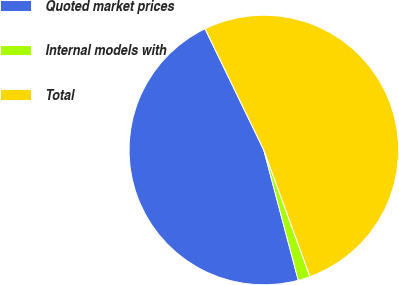<chart> <loc_0><loc_0><loc_500><loc_500><pie_chart><fcel>Quoted market prices<fcel>Internal models with<fcel>Total<nl><fcel>46.93%<fcel>1.45%<fcel>51.62%<nl></chart> 